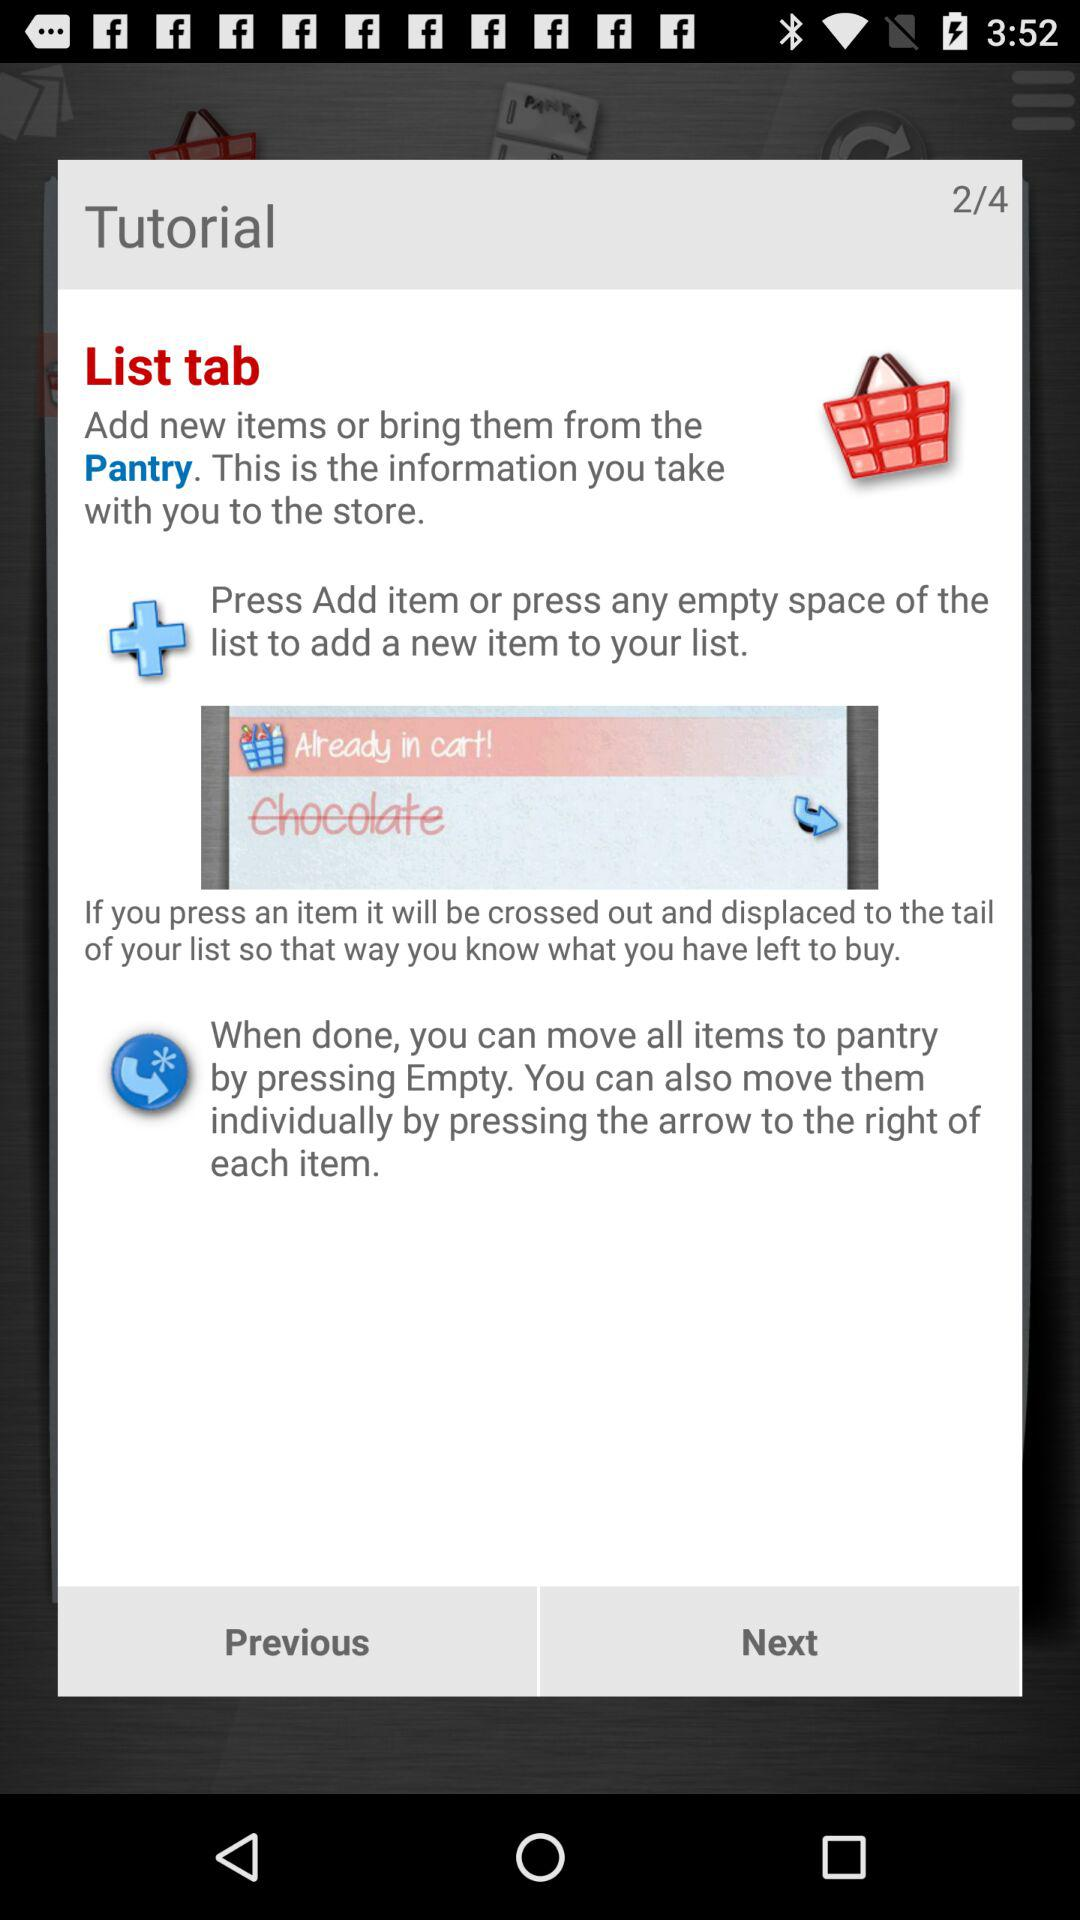How many items can I move to the pantry?
Answer the question using a single word or phrase. All 